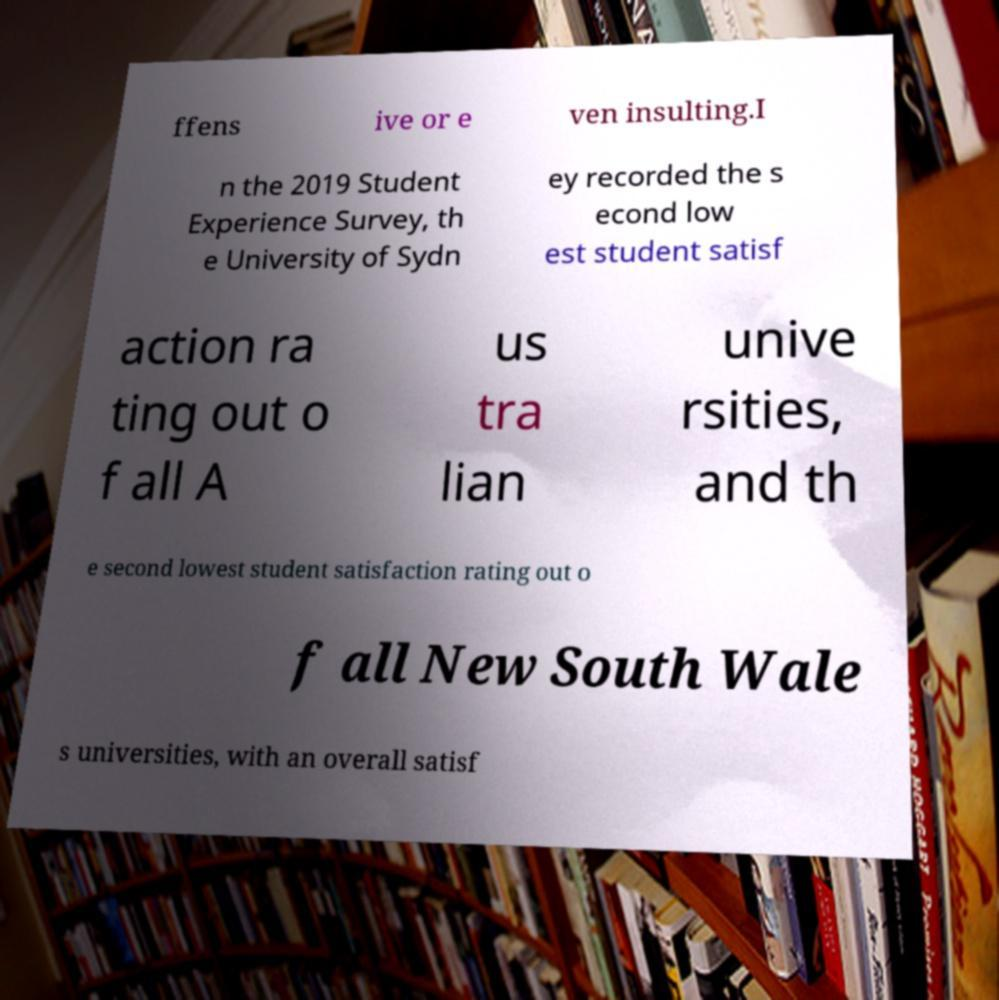Could you assist in decoding the text presented in this image and type it out clearly? ffens ive or e ven insulting.I n the 2019 Student Experience Survey, th e University of Sydn ey recorded the s econd low est student satisf action ra ting out o f all A us tra lian unive rsities, and th e second lowest student satisfaction rating out o f all New South Wale s universities, with an overall satisf 